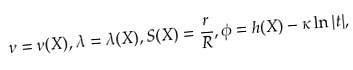<formula> <loc_0><loc_0><loc_500><loc_500>\nu = \nu ( X ) , \lambda = \lambda ( X ) , S ( X ) = \frac { r } { R } , \phi = h ( X ) - \kappa \ln | t | ,</formula> 